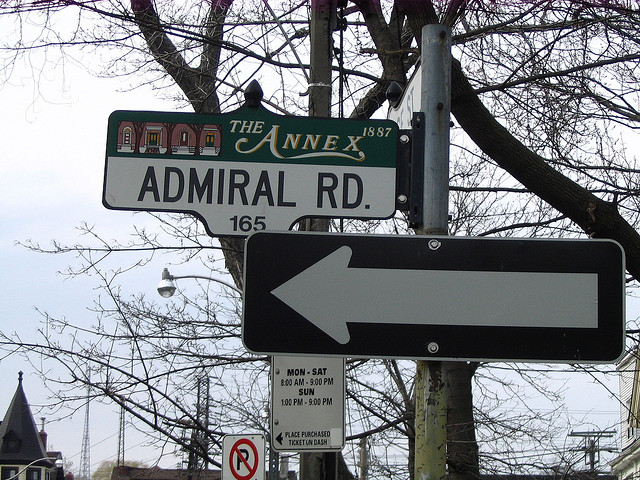Extract all visible text content from this image. THE ANNEX 1887 RD ADMIRAL 165 P DASH PURCHASED PLACE PM 9:00 PM 100 SUN PM 9:00 AM 8:00 SAT MON 